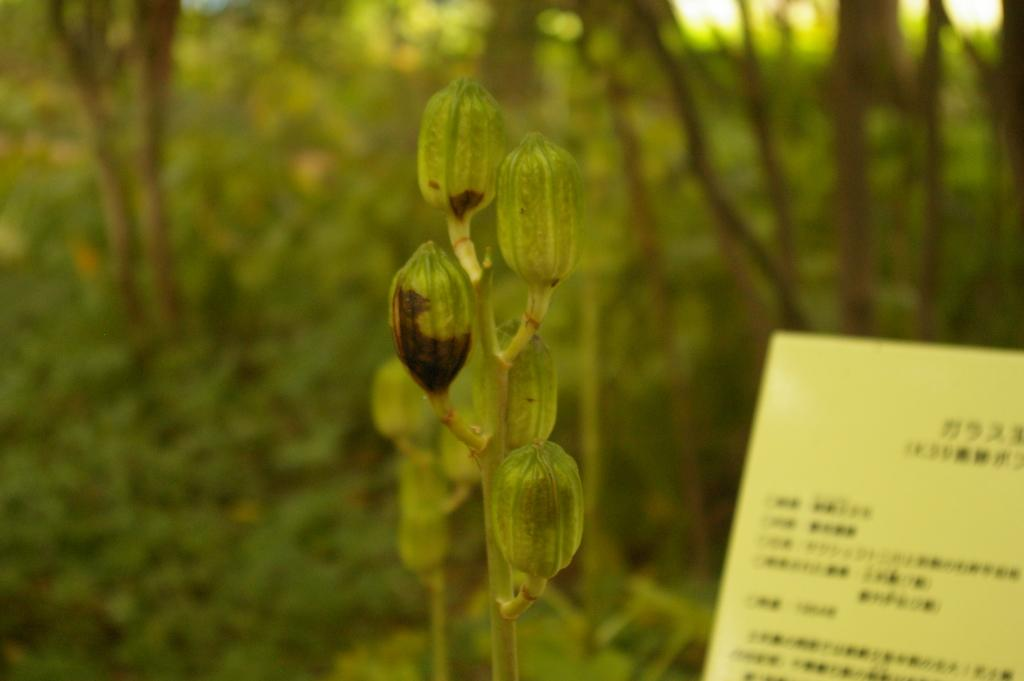What type of living organisms are present in the image? There are buds in the image. What is the other main object in the image? There is a paper in the image. Can you describe the text on the paper? There is text visible on the paper. What can be seen in the background of the image? There are trees in the background of the image. What type of rod can be seen holding up the trees in the background? There is no rod visible in the image; the trees in the background are not being held up by any visible support. 